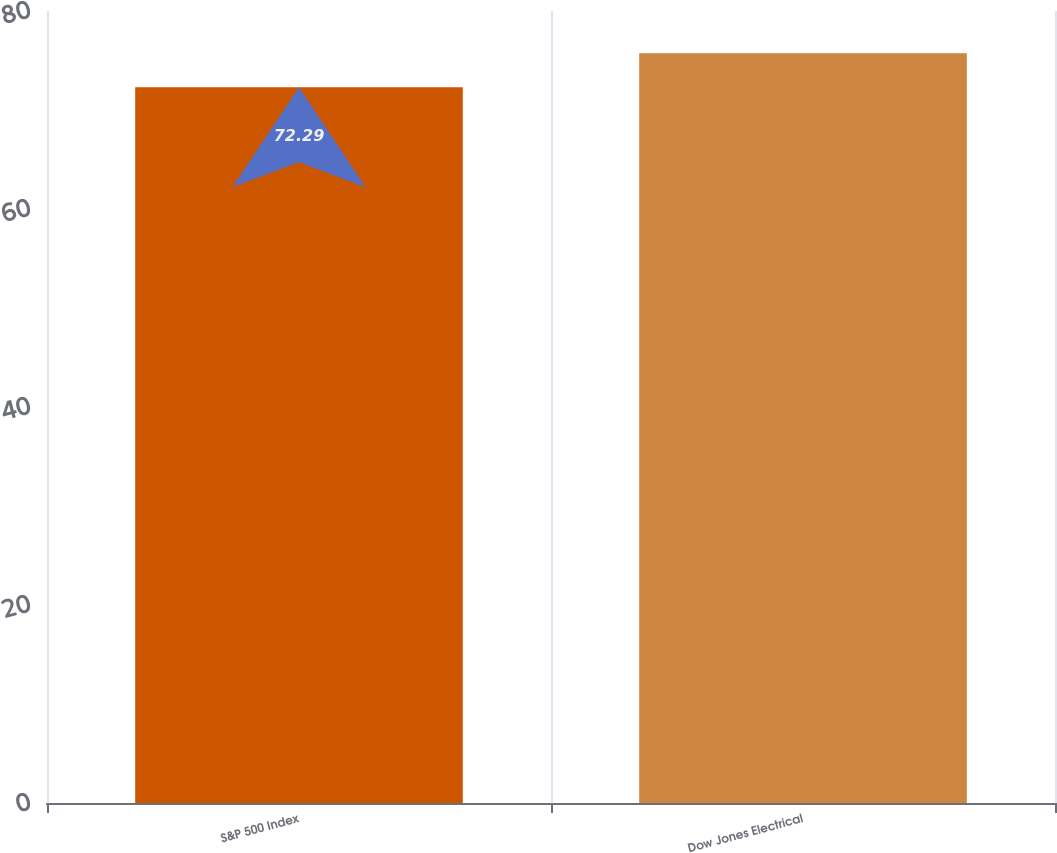<chart> <loc_0><loc_0><loc_500><loc_500><bar_chart><fcel>S&P 500 Index<fcel>Dow Jones Electrical<nl><fcel>72.29<fcel>75.74<nl></chart> 